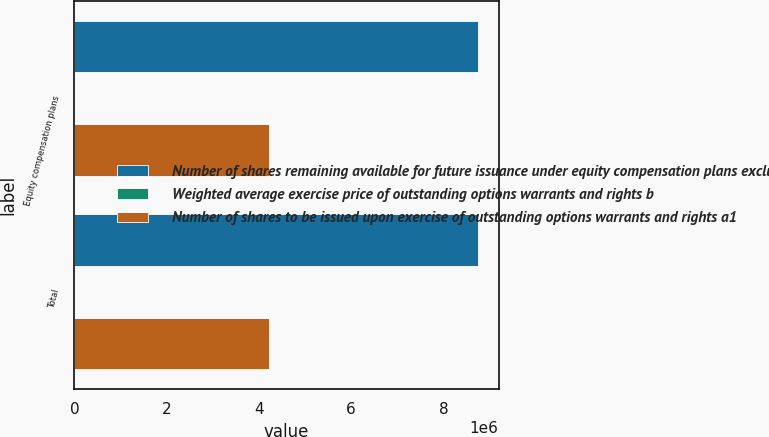Convert chart. <chart><loc_0><loc_0><loc_500><loc_500><stacked_bar_chart><ecel><fcel>Equity compensation plans<fcel>Total<nl><fcel>Number of shares remaining available for future issuance under equity compensation plans excluding shares reflected in column a c2<fcel>8.7612e+06<fcel>8.7612e+06<nl><fcel>Weighted average exercise price of outstanding options warrants and rights b<fcel>31.5<fcel>31.5<nl><fcel>Number of shares to be issued upon exercise of outstanding options warrants and rights a1<fcel>4.21506e+06<fcel>4.21506e+06<nl></chart> 